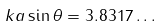Convert formula to latex. <formula><loc_0><loc_0><loc_500><loc_500>k a \sin { \theta } = 3 . 8 3 1 7 \dots</formula> 